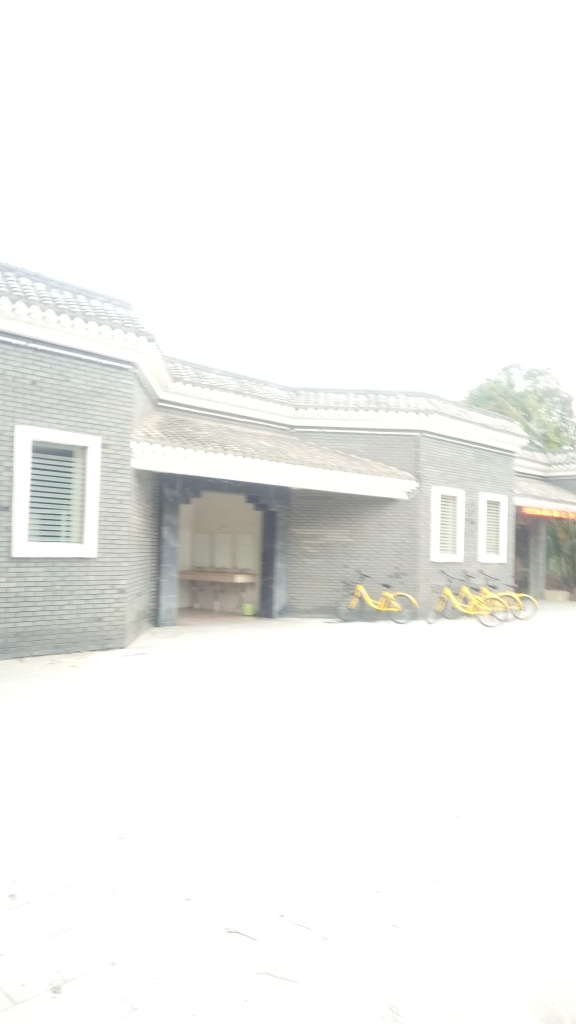Are there any quality issues with this image? Yes, the image is overexposed, resulting in loss of detail especially in the lighter areas, and the focus seems to be slightly off, making the overall scene appear blurry. These issues could significantly impact the usability of the image for certain applications. 